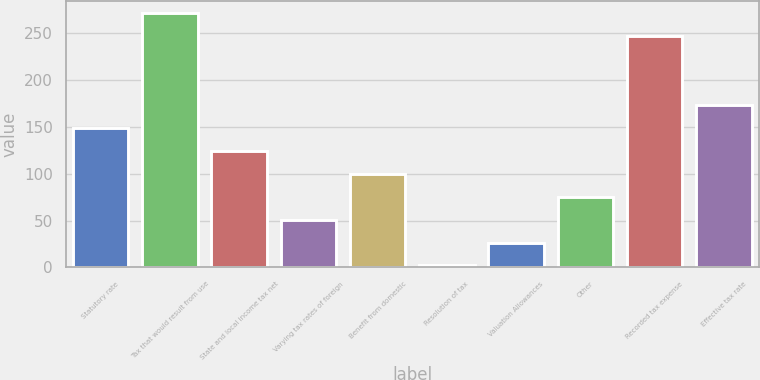Convert chart to OTSL. <chart><loc_0><loc_0><loc_500><loc_500><bar_chart><fcel>Statutory rate<fcel>Tax that would result from use<fcel>State and local income tax net<fcel>Varying tax rates of foreign<fcel>Benefit from domestic<fcel>Resolution of tax<fcel>Valuation Allowances<fcel>Other<fcel>Recorded tax expense<fcel>Effective tax rate<nl><fcel>149.12<fcel>271.39<fcel>124.63<fcel>51.16<fcel>100.14<fcel>2.18<fcel>26.67<fcel>75.65<fcel>246.9<fcel>173.61<nl></chart> 